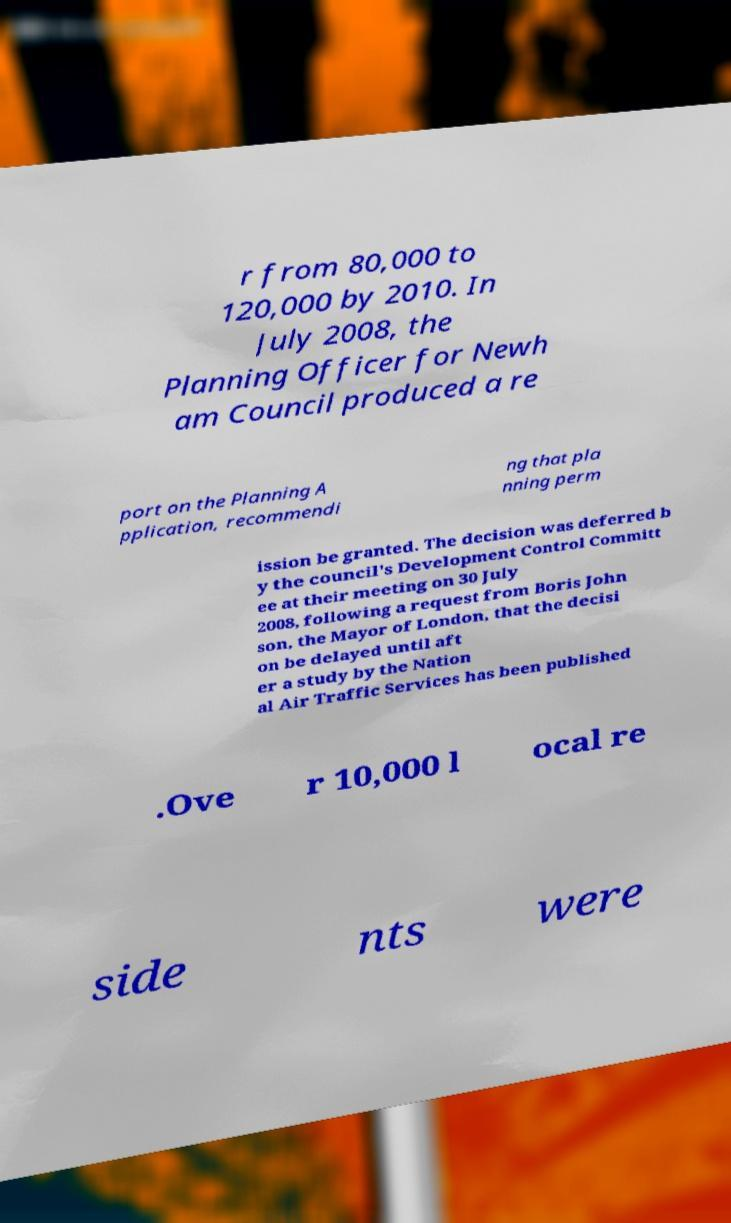Please read and relay the text visible in this image. What does it say? r from 80,000 to 120,000 by 2010. In July 2008, the Planning Officer for Newh am Council produced a re port on the Planning A pplication, recommendi ng that pla nning perm ission be granted. The decision was deferred b y the council's Development Control Committ ee at their meeting on 30 July 2008, following a request from Boris John son, the Mayor of London, that the decisi on be delayed until aft er a study by the Nation al Air Traffic Services has been published .Ove r 10,000 l ocal re side nts were 